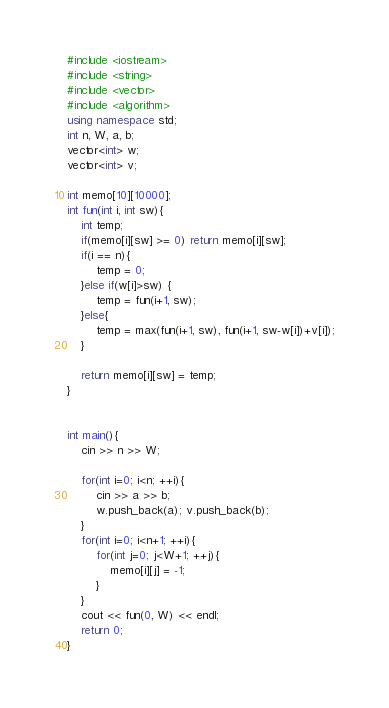Convert code to text. <code><loc_0><loc_0><loc_500><loc_500><_C++_>#include <iostream>
#include <string>
#include <vector>
#include <algorithm>
using namespace std;
int n, W, a, b;
vector<int> w;
vector<int> v;

int memo[10][10000];
int fun(int i, int sw){
    int temp;
    if(memo[i][sw] >= 0) return memo[i][sw];
    if(i == n){
        temp = 0;
    }else if(w[i]>sw) {
        temp = fun(i+1, sw);
    }else{
        temp = max(fun(i+1, sw), fun(i+1, sw-w[i])+v[i]);
    }
    
    return memo[i][sw] = temp;
}
    

int main(){
    cin >> n >> W;
    
    for(int i=0; i<n; ++i){
        cin >> a >> b;
        w.push_back(a); v.push_back(b);
    }
    for(int i=0; i<n+1; ++i){
        for(int j=0; j<W+1; ++j){
            memo[i][j] = -1;
        }
    }
    cout << fun(0, W) << endl;
    return 0;
}
</code> 